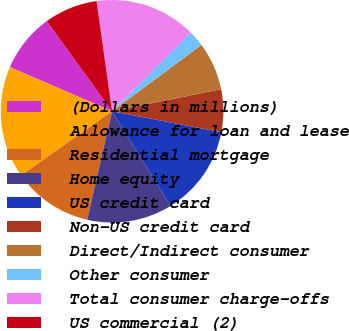Convert chart. <chart><loc_0><loc_0><loc_500><loc_500><pie_chart><fcel>(Dollars in millions)<fcel>Allowance for loan and lease<fcel>Residential mortgage<fcel>Home equity<fcel>US credit card<fcel>Non-US credit card<fcel>Direct/Indirect consumer<fcel>Other consumer<fcel>Total consumer charge-offs<fcel>US commercial (2)<nl><fcel>8.53%<fcel>16.27%<fcel>11.63%<fcel>12.4%<fcel>13.18%<fcel>6.2%<fcel>6.98%<fcel>2.33%<fcel>14.73%<fcel>7.75%<nl></chart> 